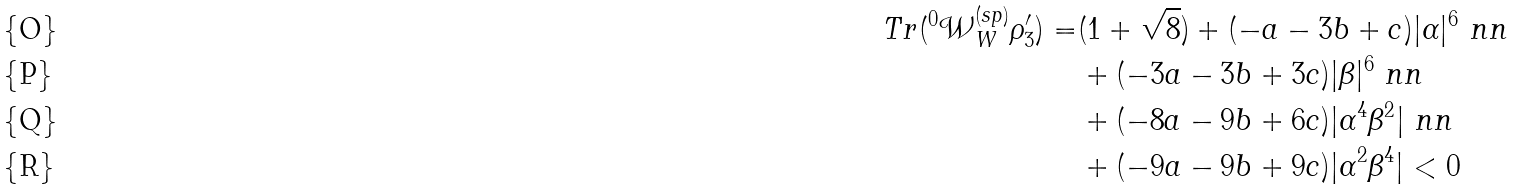Convert formula to latex. <formula><loc_0><loc_0><loc_500><loc_500>T r ( ^ { 0 } \mathcal { W } _ { W } ^ { ( s p ) } \rho _ { 3 } ^ { \prime } ) = & ( 1 + \sqrt { 8 } ) + ( - a - 3 b + c ) | \alpha | ^ { 6 } \ n n \\ & + ( - 3 a - 3 b + 3 c ) | \beta | ^ { 6 } \ n n \\ & + ( - 8 a - 9 b + 6 c ) | \alpha ^ { 4 } \beta ^ { 2 } | \ n n \\ & + ( - 9 a - 9 b + 9 c ) | \alpha ^ { 2 } \beta ^ { 4 } | < 0</formula> 